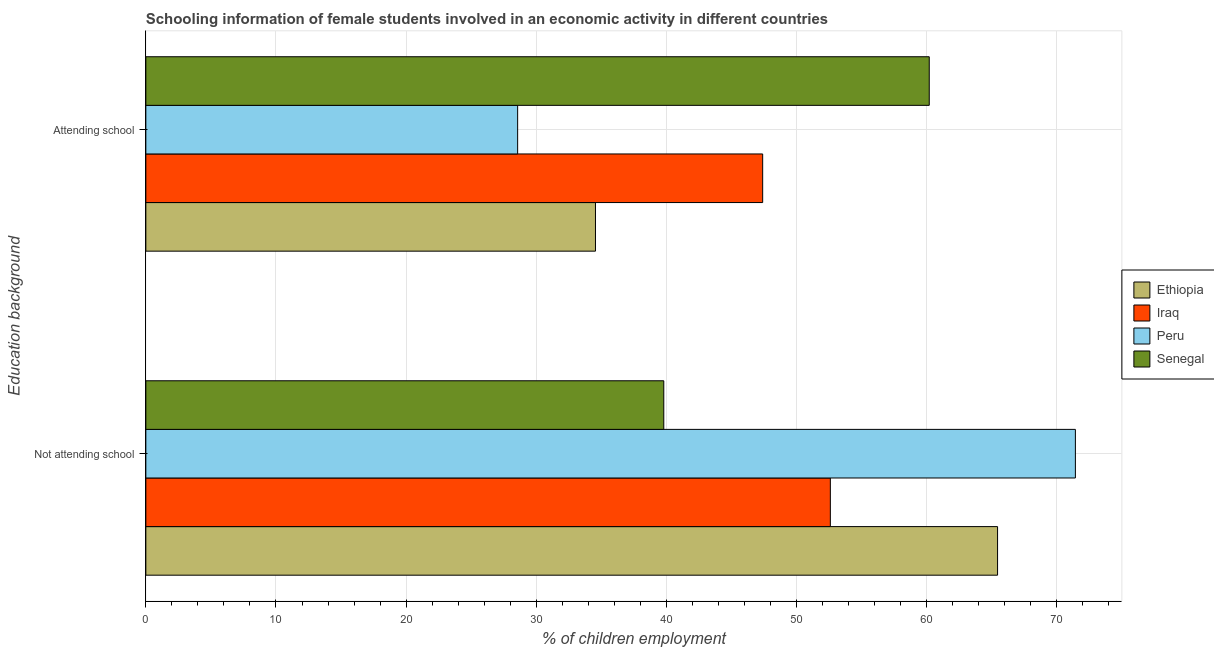How many different coloured bars are there?
Your response must be concise. 4. Are the number of bars on each tick of the Y-axis equal?
Your answer should be compact. Yes. What is the label of the 1st group of bars from the top?
Your answer should be very brief. Attending school. What is the percentage of employed females who are not attending school in Senegal?
Provide a succinct answer. 39.8. Across all countries, what is the maximum percentage of employed females who are not attending school?
Offer a very short reply. 71.43. Across all countries, what is the minimum percentage of employed females who are not attending school?
Offer a terse response. 39.8. In which country was the percentage of employed females who are attending school maximum?
Make the answer very short. Senegal. In which country was the percentage of employed females who are not attending school minimum?
Provide a short and direct response. Senegal. What is the total percentage of employed females who are not attending school in the graph?
Ensure brevity in your answer.  229.28. What is the difference between the percentage of employed females who are not attending school in Ethiopia and that in Peru?
Your answer should be very brief. -5.98. What is the difference between the percentage of employed females who are not attending school in Ethiopia and the percentage of employed females who are attending school in Iraq?
Keep it short and to the point. 18.05. What is the average percentage of employed females who are not attending school per country?
Ensure brevity in your answer.  57.32. What is the difference between the percentage of employed females who are attending school and percentage of employed females who are not attending school in Senegal?
Keep it short and to the point. 20.4. What is the ratio of the percentage of employed females who are not attending school in Iraq to that in Ethiopia?
Your answer should be compact. 0.8. What does the 4th bar from the top in Not attending school represents?
Give a very brief answer. Ethiopia. What does the 2nd bar from the bottom in Attending school represents?
Keep it short and to the point. Iraq. How many countries are there in the graph?
Offer a terse response. 4. Does the graph contain any zero values?
Ensure brevity in your answer.  No. How many legend labels are there?
Ensure brevity in your answer.  4. What is the title of the graph?
Your answer should be very brief. Schooling information of female students involved in an economic activity in different countries. Does "Iraq" appear as one of the legend labels in the graph?
Offer a terse response. Yes. What is the label or title of the X-axis?
Ensure brevity in your answer.  % of children employment. What is the label or title of the Y-axis?
Your answer should be compact. Education background. What is the % of children employment in Ethiopia in Not attending school?
Provide a short and direct response. 65.45. What is the % of children employment in Iraq in Not attending school?
Provide a succinct answer. 52.6. What is the % of children employment in Peru in Not attending school?
Your response must be concise. 71.43. What is the % of children employment in Senegal in Not attending school?
Offer a terse response. 39.8. What is the % of children employment of Ethiopia in Attending school?
Your answer should be very brief. 34.55. What is the % of children employment in Iraq in Attending school?
Your answer should be compact. 47.4. What is the % of children employment in Peru in Attending school?
Keep it short and to the point. 28.57. What is the % of children employment of Senegal in Attending school?
Offer a very short reply. 60.2. Across all Education background, what is the maximum % of children employment in Ethiopia?
Offer a terse response. 65.45. Across all Education background, what is the maximum % of children employment of Iraq?
Provide a succinct answer. 52.6. Across all Education background, what is the maximum % of children employment of Peru?
Your answer should be compact. 71.43. Across all Education background, what is the maximum % of children employment of Senegal?
Your answer should be compact. 60.2. Across all Education background, what is the minimum % of children employment of Ethiopia?
Make the answer very short. 34.55. Across all Education background, what is the minimum % of children employment in Iraq?
Provide a succinct answer. 47.4. Across all Education background, what is the minimum % of children employment of Peru?
Give a very brief answer. 28.57. Across all Education background, what is the minimum % of children employment of Senegal?
Keep it short and to the point. 39.8. What is the total % of children employment of Ethiopia in the graph?
Your response must be concise. 100. What is the difference between the % of children employment of Ethiopia in Not attending school and that in Attending school?
Provide a succinct answer. 30.9. What is the difference between the % of children employment of Peru in Not attending school and that in Attending school?
Give a very brief answer. 42.86. What is the difference between the % of children employment of Senegal in Not attending school and that in Attending school?
Offer a very short reply. -20.4. What is the difference between the % of children employment in Ethiopia in Not attending school and the % of children employment in Iraq in Attending school?
Give a very brief answer. 18.05. What is the difference between the % of children employment in Ethiopia in Not attending school and the % of children employment in Peru in Attending school?
Keep it short and to the point. 36.88. What is the difference between the % of children employment of Ethiopia in Not attending school and the % of children employment of Senegal in Attending school?
Keep it short and to the point. 5.25. What is the difference between the % of children employment of Iraq in Not attending school and the % of children employment of Peru in Attending school?
Your answer should be compact. 24.03. What is the difference between the % of children employment in Peru in Not attending school and the % of children employment in Senegal in Attending school?
Make the answer very short. 11.23. What is the average % of children employment in Ethiopia per Education background?
Offer a very short reply. 50. What is the average % of children employment in Peru per Education background?
Give a very brief answer. 50. What is the average % of children employment in Senegal per Education background?
Your answer should be compact. 50. What is the difference between the % of children employment of Ethiopia and % of children employment of Iraq in Not attending school?
Keep it short and to the point. 12.85. What is the difference between the % of children employment in Ethiopia and % of children employment in Peru in Not attending school?
Your answer should be very brief. -5.98. What is the difference between the % of children employment of Ethiopia and % of children employment of Senegal in Not attending school?
Offer a terse response. 25.65. What is the difference between the % of children employment in Iraq and % of children employment in Peru in Not attending school?
Provide a succinct answer. -18.83. What is the difference between the % of children employment in Peru and % of children employment in Senegal in Not attending school?
Your response must be concise. 31.63. What is the difference between the % of children employment in Ethiopia and % of children employment in Iraq in Attending school?
Make the answer very short. -12.85. What is the difference between the % of children employment in Ethiopia and % of children employment in Peru in Attending school?
Ensure brevity in your answer.  5.98. What is the difference between the % of children employment of Ethiopia and % of children employment of Senegal in Attending school?
Provide a short and direct response. -25.65. What is the difference between the % of children employment of Iraq and % of children employment of Peru in Attending school?
Offer a terse response. 18.83. What is the difference between the % of children employment in Peru and % of children employment in Senegal in Attending school?
Your answer should be very brief. -31.63. What is the ratio of the % of children employment of Ethiopia in Not attending school to that in Attending school?
Your answer should be compact. 1.89. What is the ratio of the % of children employment of Iraq in Not attending school to that in Attending school?
Keep it short and to the point. 1.11. What is the ratio of the % of children employment in Peru in Not attending school to that in Attending school?
Keep it short and to the point. 2.5. What is the ratio of the % of children employment in Senegal in Not attending school to that in Attending school?
Provide a succinct answer. 0.66. What is the difference between the highest and the second highest % of children employment in Ethiopia?
Give a very brief answer. 30.9. What is the difference between the highest and the second highest % of children employment of Peru?
Offer a terse response. 42.86. What is the difference between the highest and the second highest % of children employment in Senegal?
Make the answer very short. 20.4. What is the difference between the highest and the lowest % of children employment of Ethiopia?
Keep it short and to the point. 30.9. What is the difference between the highest and the lowest % of children employment in Peru?
Offer a terse response. 42.86. What is the difference between the highest and the lowest % of children employment of Senegal?
Provide a short and direct response. 20.4. 